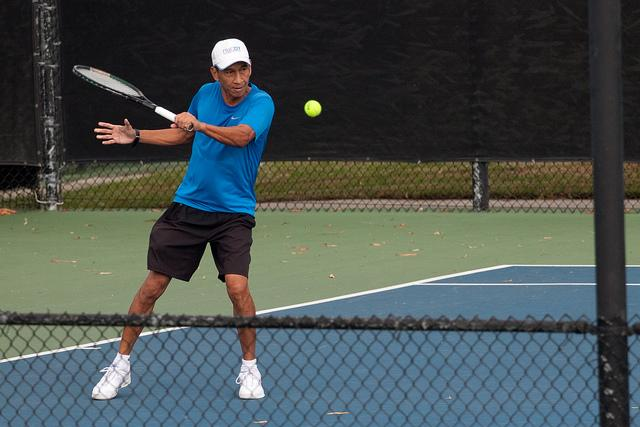What type of shot is this man making? backhand 